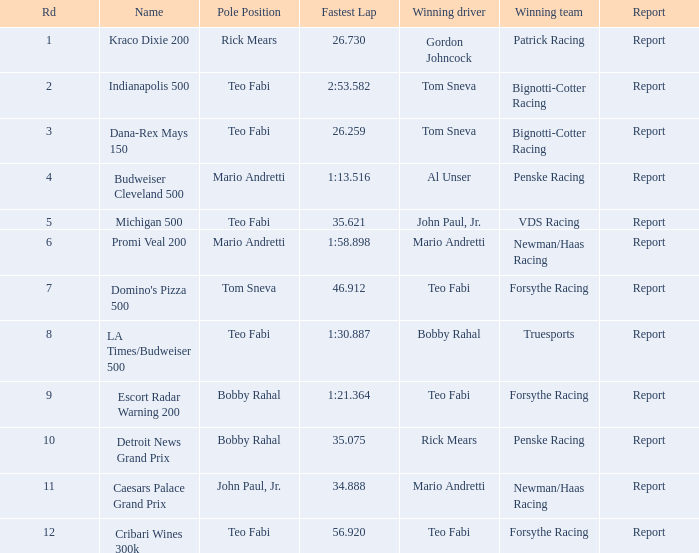How many reports are there in the race that Forsythe Racing won and Teo Fabi had the pole position in? 1.0. Would you be able to parse every entry in this table? {'header': ['Rd', 'Name', 'Pole Position', 'Fastest Lap', 'Winning driver', 'Winning team', 'Report'], 'rows': [['1', 'Kraco Dixie 200', 'Rick Mears', '26.730', 'Gordon Johncock', 'Patrick Racing', 'Report'], ['2', 'Indianapolis 500', 'Teo Fabi', '2:53.582', 'Tom Sneva', 'Bignotti-Cotter Racing', 'Report'], ['3', 'Dana-Rex Mays 150', 'Teo Fabi', '26.259', 'Tom Sneva', 'Bignotti-Cotter Racing', 'Report'], ['4', 'Budweiser Cleveland 500', 'Mario Andretti', '1:13.516', 'Al Unser', 'Penske Racing', 'Report'], ['5', 'Michigan 500', 'Teo Fabi', '35.621', 'John Paul, Jr.', 'VDS Racing', 'Report'], ['6', 'Promi Veal 200', 'Mario Andretti', '1:58.898', 'Mario Andretti', 'Newman/Haas Racing', 'Report'], ['7', "Domino's Pizza 500", 'Tom Sneva', '46.912', 'Teo Fabi', 'Forsythe Racing', 'Report'], ['8', 'LA Times/Budweiser 500', 'Teo Fabi', '1:30.887', 'Bobby Rahal', 'Truesports', 'Report'], ['9', 'Escort Radar Warning 200', 'Bobby Rahal', '1:21.364', 'Teo Fabi', 'Forsythe Racing', 'Report'], ['10', 'Detroit News Grand Prix', 'Bobby Rahal', '35.075', 'Rick Mears', 'Penske Racing', 'Report'], ['11', 'Caesars Palace Grand Prix', 'John Paul, Jr.', '34.888', 'Mario Andretti', 'Newman/Haas Racing', 'Report'], ['12', 'Cribari Wines 300k', 'Teo Fabi', '56.920', 'Teo Fabi', 'Forsythe Racing', 'Report']]} 